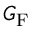<formula> <loc_0><loc_0><loc_500><loc_500>G _ { F }</formula> 